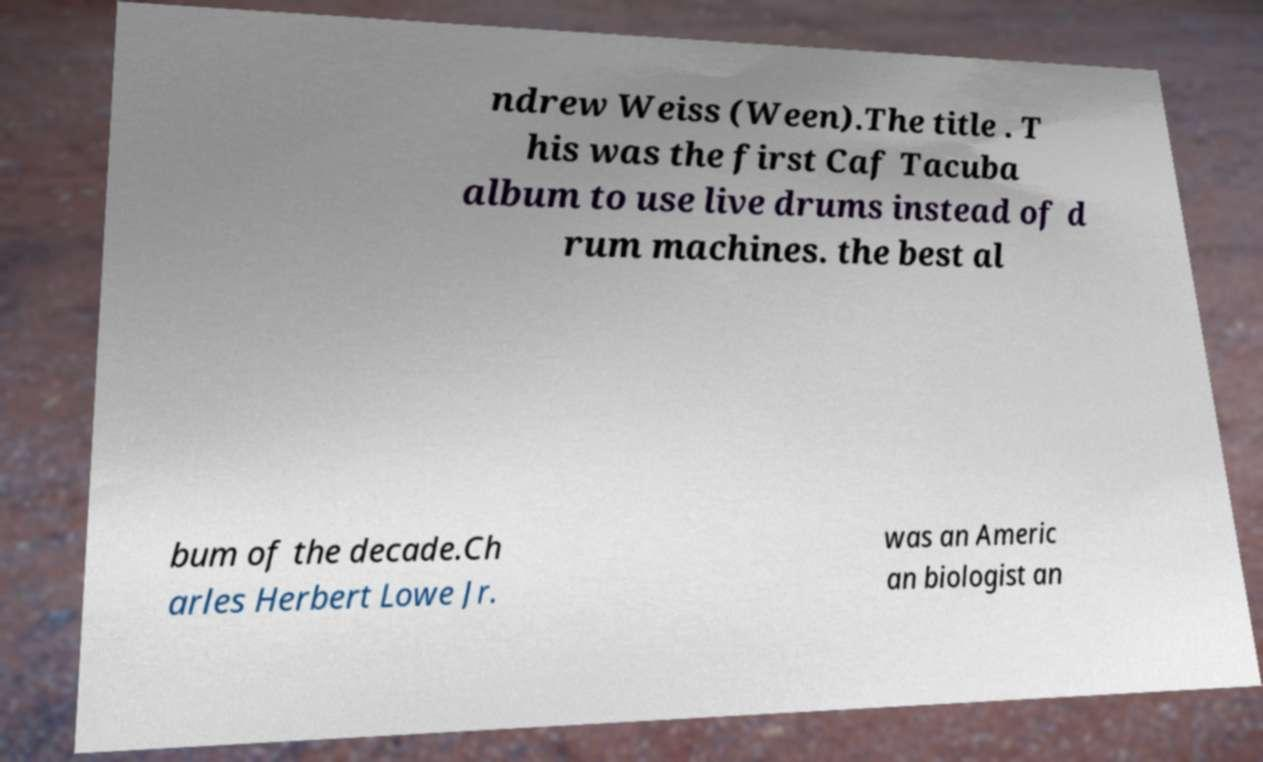There's text embedded in this image that I need extracted. Can you transcribe it verbatim? ndrew Weiss (Ween).The title . T his was the first Caf Tacuba album to use live drums instead of d rum machines. the best al bum of the decade.Ch arles Herbert Lowe Jr. was an Americ an biologist an 